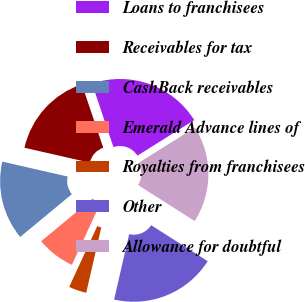<chart> <loc_0><loc_0><loc_500><loc_500><pie_chart><fcel>Loans to franchisees<fcel>Receivables for tax<fcel>CashBack receivables<fcel>Emerald Advance lines of<fcel>Royalties from franchisees<fcel>Other<fcel>Allowance for doubtful<nl><fcel>21.27%<fcel>16.25%<fcel>14.58%<fcel>7.1%<fcel>3.28%<fcel>19.6%<fcel>17.92%<nl></chart> 